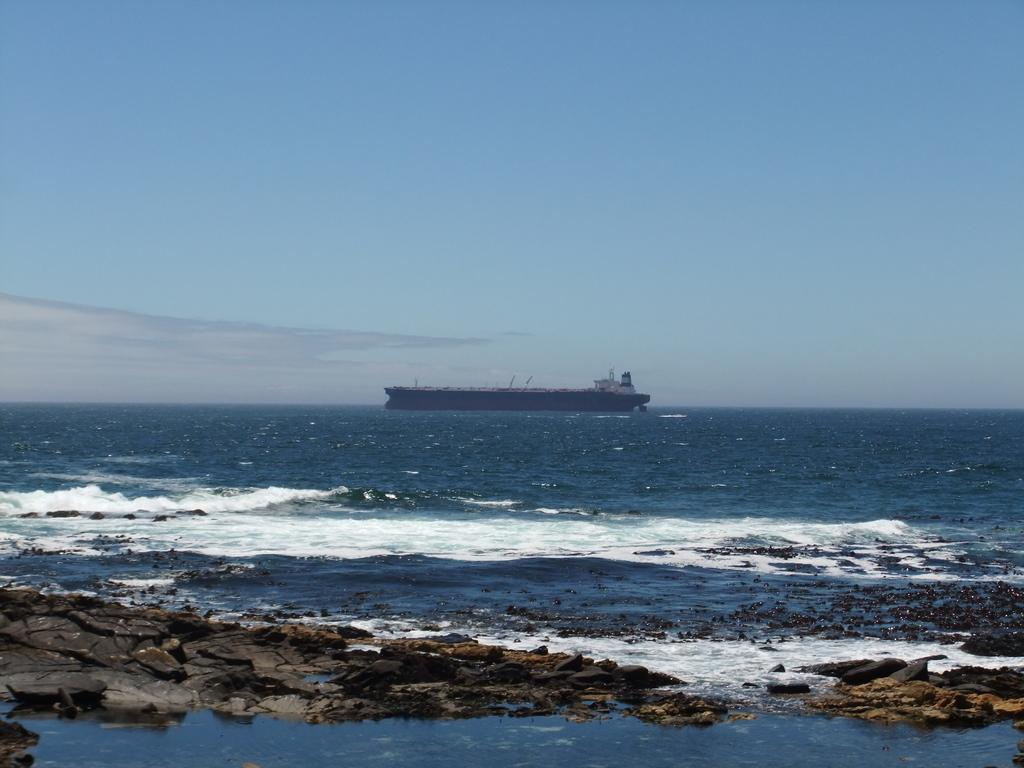What is the main subject in the center of the image? There is a ship in the center of the image. What is located at the bottom of the image? There is water and rocks at the bottom of the image. What can be seen at the top of the image? The sky is visible at the top of the image. What type of prison can be seen on the page in the image? There is no prison or page present in the image; it features a ship, water, rocks, and the sky. 